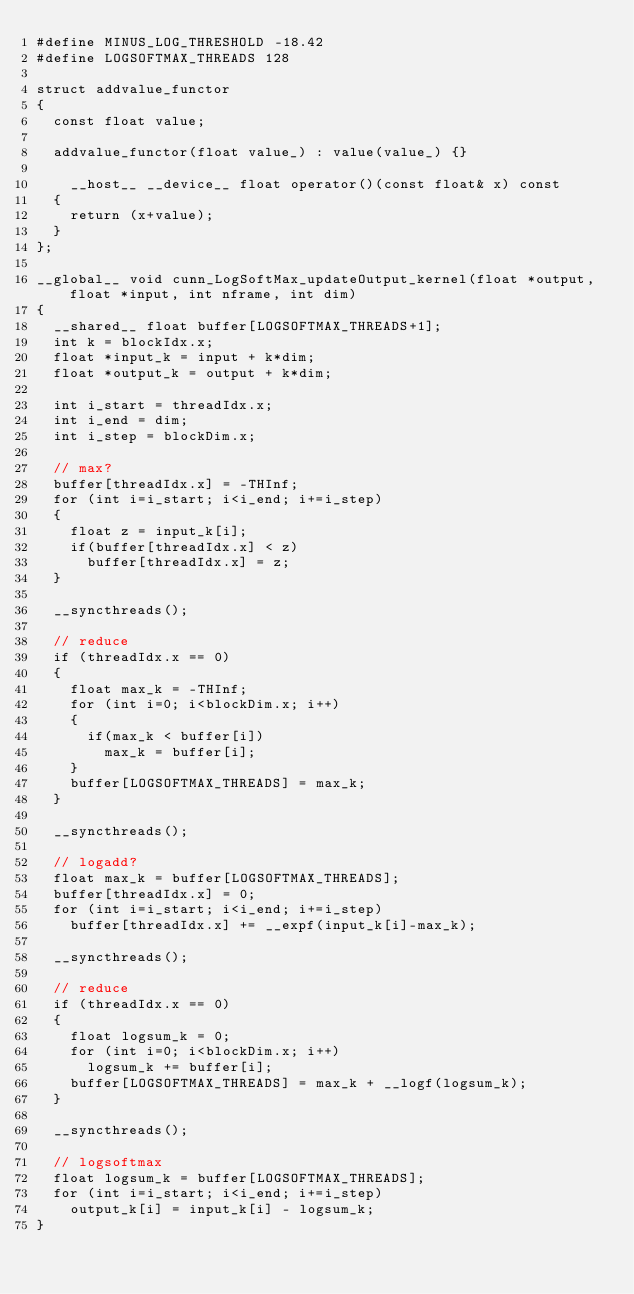<code> <loc_0><loc_0><loc_500><loc_500><_Cuda_>#define MINUS_LOG_THRESHOLD -18.42
#define LOGSOFTMAX_THREADS 128

struct addvalue_functor
{
  const float value;

  addvalue_functor(float value_) : value(value_) {}

    __host__ __device__ float operator()(const float& x) const
  {
    return (x+value);
  }
};

__global__ void cunn_LogSoftMax_updateOutput_kernel(float *output, float *input, int nframe, int dim)
{
  __shared__ float buffer[LOGSOFTMAX_THREADS+1];
  int k = blockIdx.x;
  float *input_k = input + k*dim;
  float *output_k = output + k*dim;

  int i_start = threadIdx.x;
  int i_end = dim;
  int i_step = blockDim.x;

  // max?
  buffer[threadIdx.x] = -THInf;
  for (int i=i_start; i<i_end; i+=i_step)
  {
    float z = input_k[i];
    if(buffer[threadIdx.x] < z)
      buffer[threadIdx.x] = z;
  }

  __syncthreads();

  // reduce
  if (threadIdx.x == 0)
  {
    float max_k = -THInf;
    for (int i=0; i<blockDim.x; i++)
    {
      if(max_k < buffer[i])
        max_k = buffer[i];
    }
    buffer[LOGSOFTMAX_THREADS] = max_k;
  }

  __syncthreads();

  // logadd?
  float max_k = buffer[LOGSOFTMAX_THREADS];
  buffer[threadIdx.x] = 0;
  for (int i=i_start; i<i_end; i+=i_step)
    buffer[threadIdx.x] += __expf(input_k[i]-max_k);

  __syncthreads();

  // reduce
  if (threadIdx.x == 0)
  {
    float logsum_k = 0;
    for (int i=0; i<blockDim.x; i++)
      logsum_k += buffer[i];
    buffer[LOGSOFTMAX_THREADS] = max_k + __logf(logsum_k);
  }

  __syncthreads();

  // logsoftmax
  float logsum_k = buffer[LOGSOFTMAX_THREADS];
  for (int i=i_start; i<i_end; i+=i_step)
    output_k[i] = input_k[i] - logsum_k;
}

</code> 